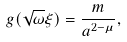Convert formula to latex. <formula><loc_0><loc_0><loc_500><loc_500>g ( \sqrt { \omega } \xi ) = \frac { m } { a ^ { 2 - \mu } } ,</formula> 